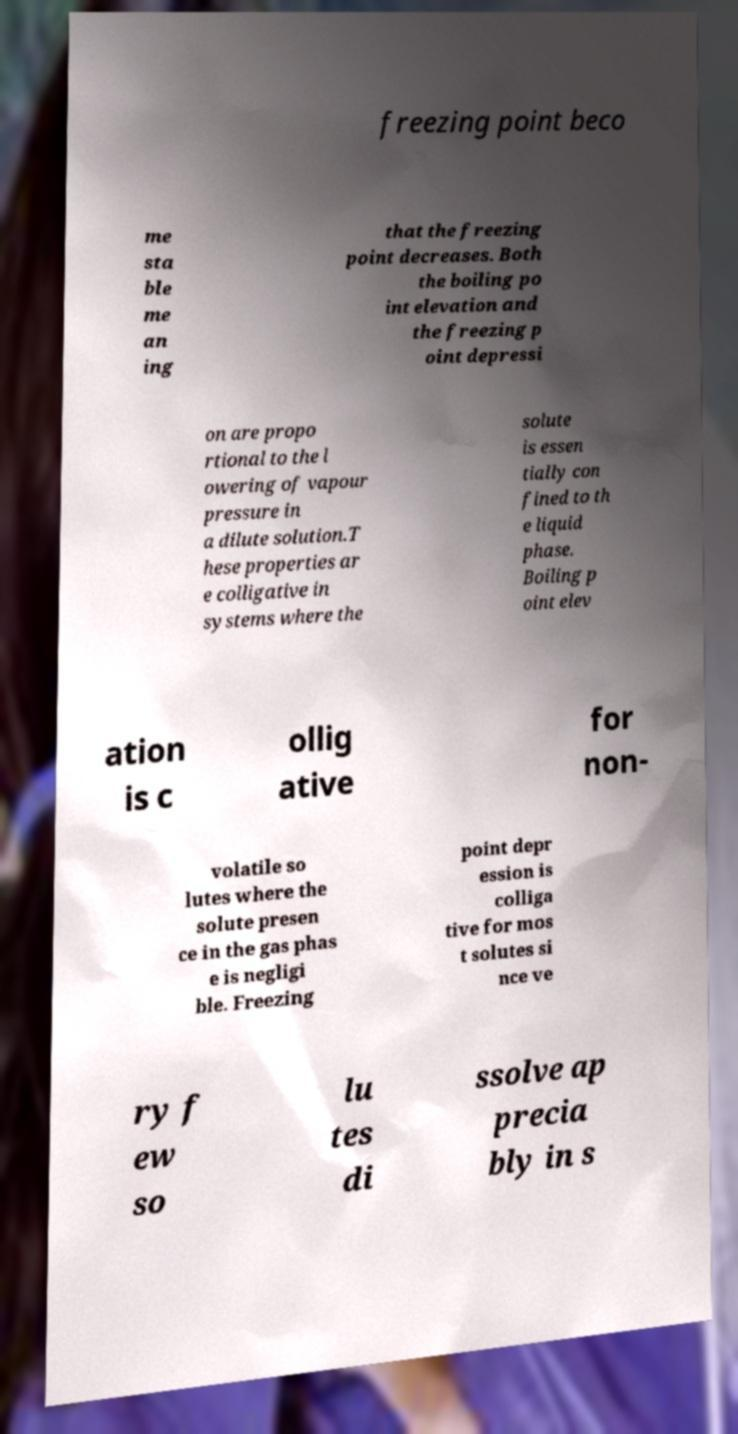What messages or text are displayed in this image? I need them in a readable, typed format. freezing point beco me sta ble me an ing that the freezing point decreases. Both the boiling po int elevation and the freezing p oint depressi on are propo rtional to the l owering of vapour pressure in a dilute solution.T hese properties ar e colligative in systems where the solute is essen tially con fined to th e liquid phase. Boiling p oint elev ation is c ollig ative for non- volatile so lutes where the solute presen ce in the gas phas e is negligi ble. Freezing point depr ession is colliga tive for mos t solutes si nce ve ry f ew so lu tes di ssolve ap precia bly in s 